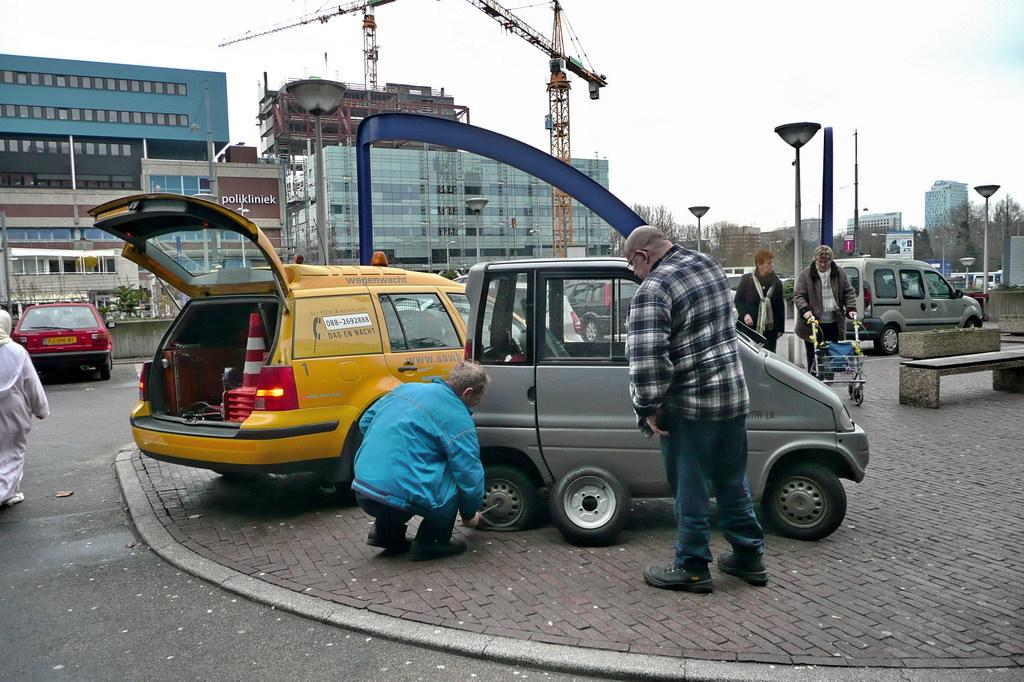<image>
Describe the image concisely. Two men are looking at a tire while one man fixes it next to a yellow car with a sticker that says wegenwacht. 